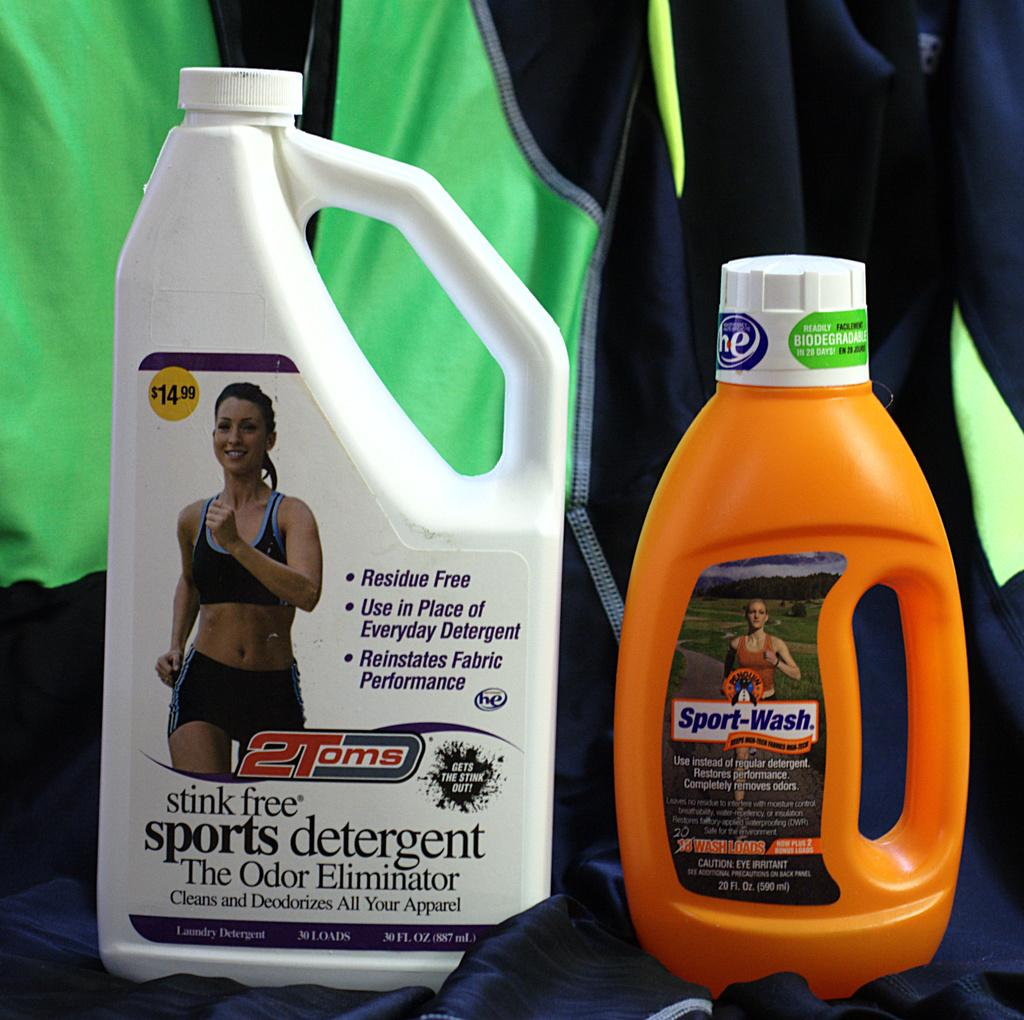What objects can be seen in the image? There are bottles in the image. Where are the bottles placed? The bottles are on a black cloth. What color is the cloth in the background of the image? There is a green cloth in the background of the image. What type of pencil can be seen on the green cloth in the image? There is no pencil present on the green cloth in the image. 